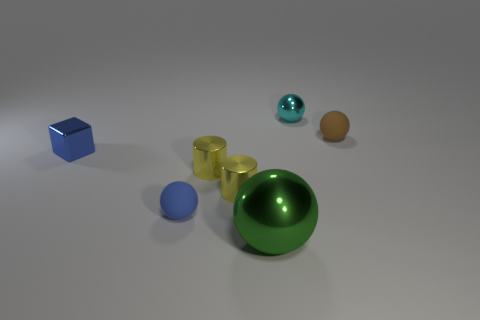Is the color of the tiny rubber ball that is on the left side of the big green metallic ball the same as the metallic block?
Give a very brief answer. Yes. There is a small matte thing that is the same color as the tiny block; what is its shape?
Offer a terse response. Sphere. There is a tiny blue metallic thing; how many spheres are in front of it?
Keep it short and to the point. 2. What is the size of the green ball?
Ensure brevity in your answer.  Large. There is a metallic block that is the same size as the brown rubber thing; what is its color?
Provide a short and direct response. Blue. Are there any small objects of the same color as the block?
Ensure brevity in your answer.  Yes. What material is the brown ball?
Your response must be concise. Rubber. How many blue matte cubes are there?
Provide a short and direct response. 0. Is the color of the matte sphere that is on the left side of the small cyan shiny ball the same as the tiny metal cube that is behind the large green metal thing?
Make the answer very short. Yes. How many other things are there of the same size as the blue matte ball?
Your answer should be very brief. 5. 